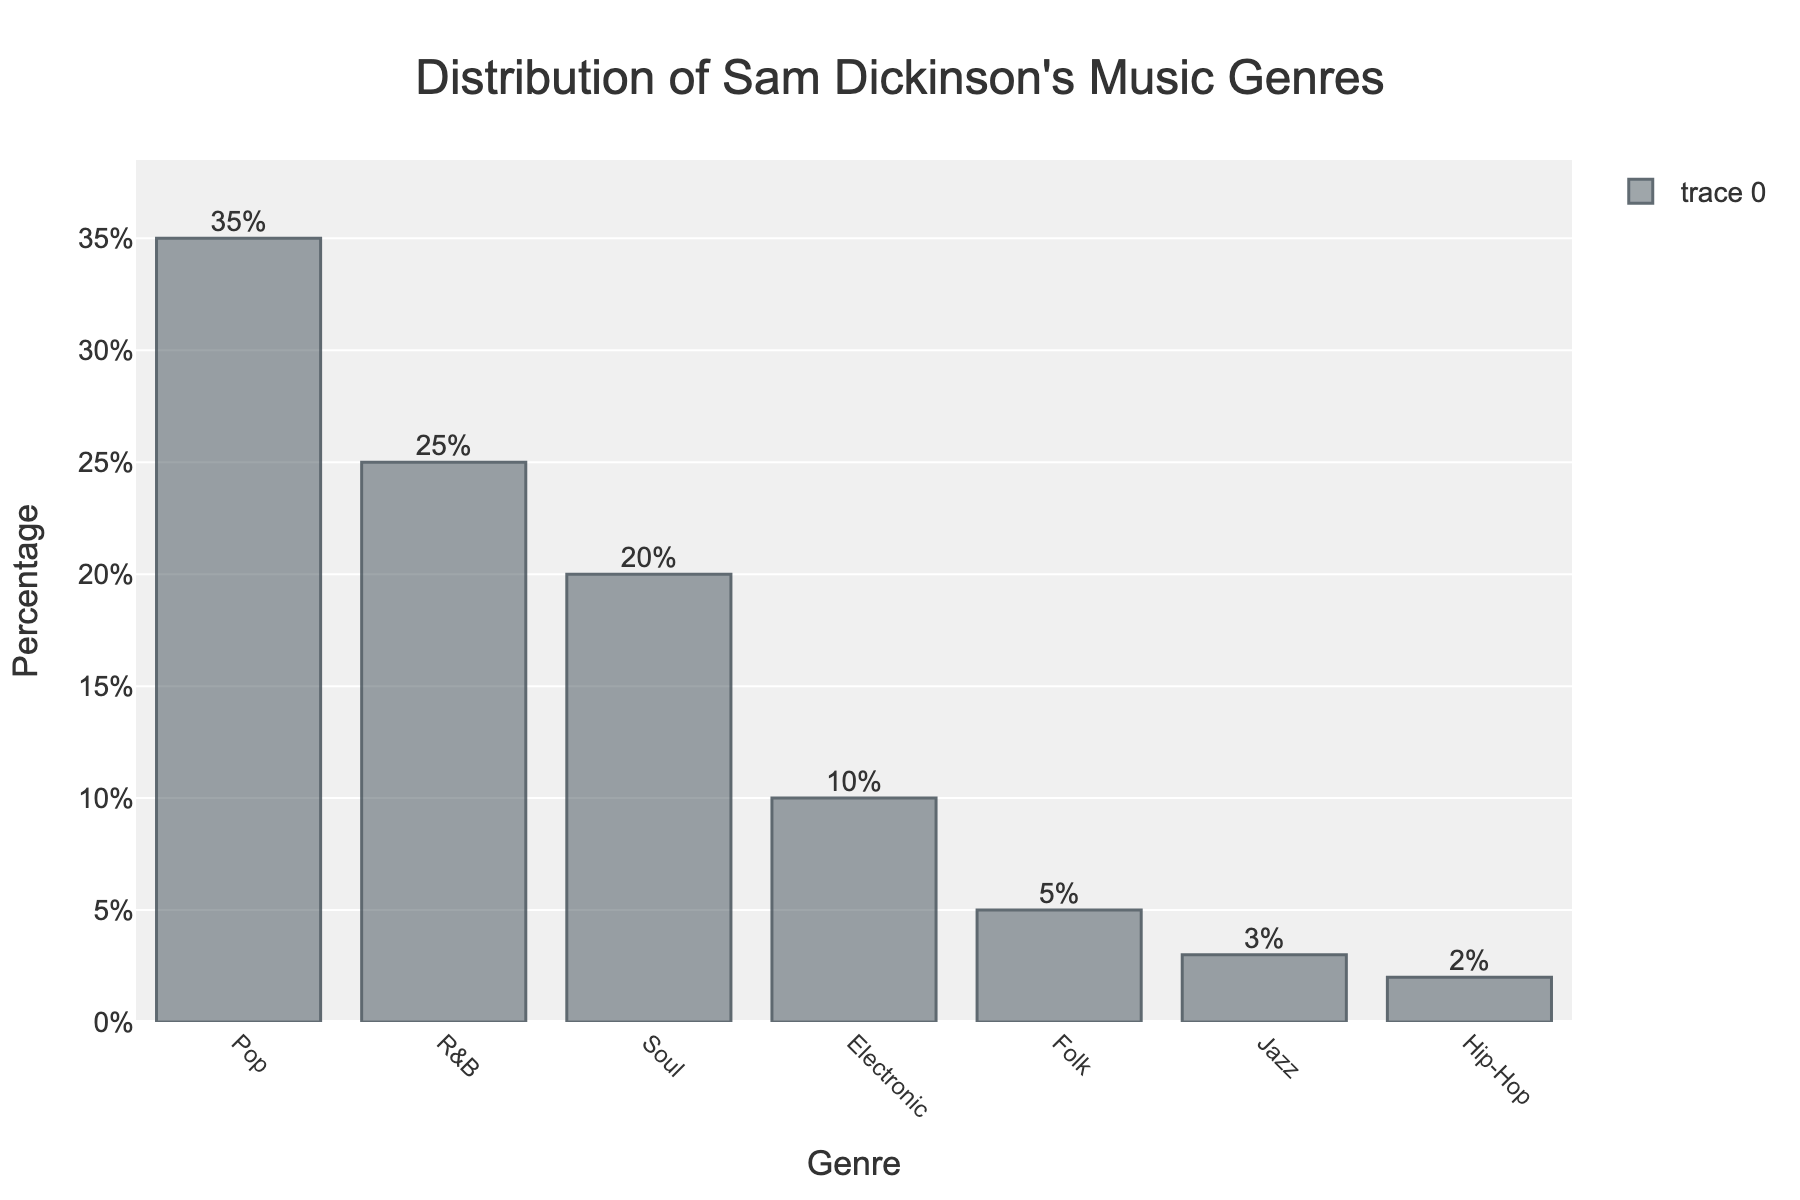What percentage of Sam Dickinson’s discography falls under the Pop genre? Look at the height of the Pop bar, which is labeled with its percentage value.
Answer: 35% Which genre has a higher percentage, Soul or Electronic? Compare the heights of the bars for Soul and Electronic. Soul is 20% while Electronic is 10%.
Answer: Soul How much more of Sam Dickinson's music is classified as Pop compared to Folk? Subtract the percentage value of Folk (5%) from Pop (35%).
Answer: 30% What is the combined percentage of R&B, Soul, and Electronic genres in Sam Dickinson’s music? Add the percentage values for R&B (25%), Soul (20%), and Electronic (10%). 25% + 20% + 10% = 55%.
Answer: 55% Which genres together make up less than 10% of Sam Dickinson’s music? Look for genres with percentage values collectively totaling less than 10%. Jazz is 3% and Hip-Hop is 2%, so 3% + 2% = 5% which is less than 10%.
Answer: Jazz and Hip-Hop Is the percentage of R&B music in Sam Dickinson's discography greater than the percentage of Folk and Jazz combined? Compare the R&B percentage (25%) with the sum of Folk (5%) and Jazz (3%). 5% + 3% = 8%, so 25% > 8%.
Answer: Yes What percentage of the music genres combined have less than a 5% representation in Sam Dickinson’s discography? Look at the genres with less than 5% and sum their percentages. Jazz is 3% and Hip-Hop is 2%, so 3% + 2% = 5%.
Answer: 5% How many genres have a percentage value greater than 15%? Count the genres with percentage values above 15%. Pop is 35%, R&B is 25%, and Soul is 20%, so there are 3 genres.
Answer: 3 What is the largest difference in percentage between any two consecutive genres after sorting by percentage in descending order? Subtract each consecutive pair after sorting by percentage: Pop-R&B (35% - 25% = 10%), R&B-Soul (25% - 20% = 5%), Soul-Electronic (20% - 10% = 10%), Electronic-Folk (10% - 5% = 5%), Folk-Jazz (5% - 3% = 2%), Jazz-Hip-Hop (3% - 2% = 1%). The largest difference is 10%.
Answer: 10% What proportion of the discography is made up by genres with less than 20% representation? Find the genres with less than 20% and sum their percentages. Electronic (10%), Folk (5%), Jazz (3%), and Hip-Hop (2%), so 10% + 5% + 3% + 2% = 20%. Compare this to the total percentage (100%), so 20% / 100% = 0.2 or 20%.
Answer: 20% 